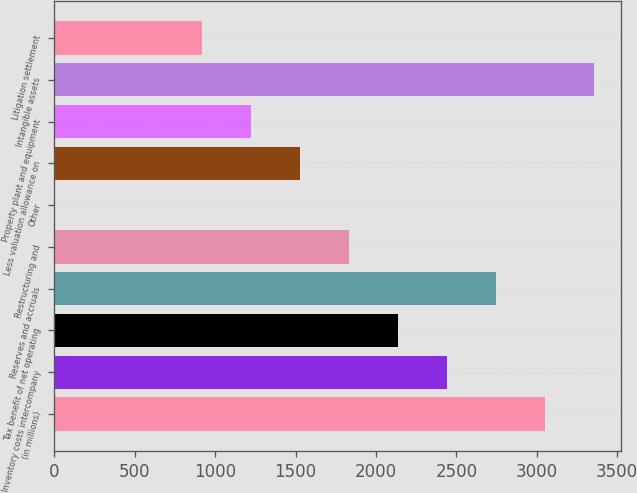Convert chart to OTSL. <chart><loc_0><loc_0><loc_500><loc_500><bar_chart><fcel>(in millions)<fcel>Inventory costs intercompany<fcel>Tax benefit of net operating<fcel>Reserves and accruals<fcel>Restructuring and<fcel>Other<fcel>Less valuation allowance on<fcel>Property plant and equipment<fcel>Intangible assets<fcel>Litigation settlement<nl><fcel>3053<fcel>2443.4<fcel>2138.6<fcel>2748.2<fcel>1833.8<fcel>5<fcel>1529<fcel>1224.2<fcel>3357.8<fcel>919.4<nl></chart> 